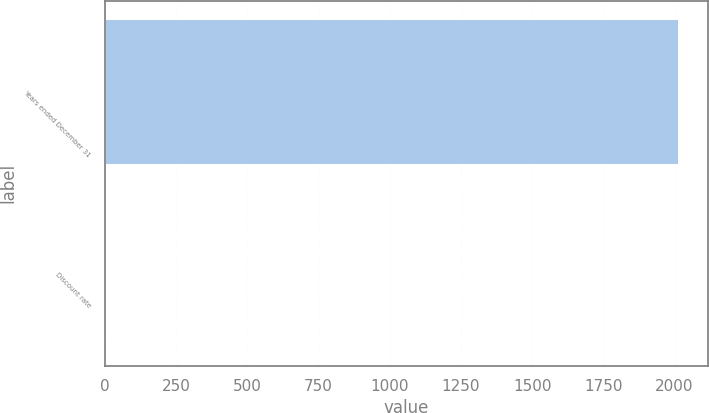Convert chart to OTSL. <chart><loc_0><loc_0><loc_500><loc_500><bar_chart><fcel>Years ended December 31<fcel>Discount rate<nl><fcel>2015<fcel>4.15<nl></chart> 